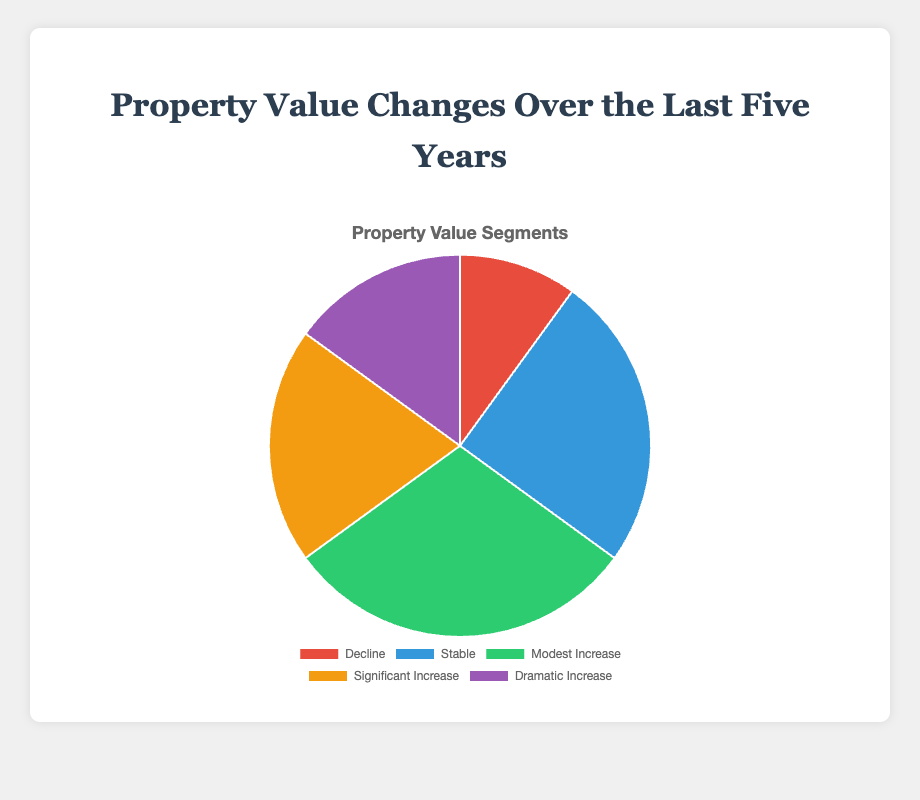Which property value segment has the highest percentage? The visual representation shows that the 'Modest Increase' section occupies the largest area of the pie chart.
Answer: Modest Increase Which two segments together account for exactly 50% of the property values? 'Stable' has 25% and 'Modest Increase' has 30%. Adding these two percentages results in 55%, which is incorrect. 'Significant Increase' has 20%, and adding 'Stable' (25%) results in 45%. Combining 'Dramatic Increase' (15%) and 'Decline' (10%) yields 25%, which is also incorrect. Finally, adding 'Significant Increase' (20%) and 'Dramatic Increase' (15%) results in 35%. The correct answer is 'Stable' and 'Significant Increase'.
Answer: Stable and Significant Increase How much larger, in percentage points, is the 'Significant Increase' segment compared to the 'Decline' segment? The percentage for 'Significant Increase' is 20%, while for 'Decline' it is 10%. Subtracting the two, 20% - 10%, gives the difference.
Answer: 10% What percentage of properties have experienced an increase (modest, significant, or dramatic)? To find the total percentage of properties that have experienced an increase, add the percentages for 'Modest Increase' (30%), 'Significant Increase' (20%), and 'Dramatic Increase' (15%). The sum is 30% + 20% + 15% = 65%.
Answer: 65% Which segment has the smallest percentage, and what is that percentage? The 'Decline' segment is visually the smallest part of the pie chart. The percentage for 'Decline' is 10%.
Answer: Decline, 10% Which two segments together have the same percentage as the 'Modest Increase' segment? First, check which segments sum up to 'Modest Increase' (30%). Starting with 'Decline' (10%) and 'Stable' (25%) yields 35%, which is not correct. Checking 'Decline' (10%) and 'Significant Increase' (20%) results in 30%, which matches 'Modest Increase'. Combining 'Significant Increase' (20%) and 'Dramatic Increase' (15%) gives 35%, which is also incorrect. Thus, 'Decline' and 'Significant Increase' together give 30%.
Answer: Decline and Significant Increase How does the percentage of the 'Stable' segment compare to that of the 'Dramatic Increase' segment? The 'Stable' segment accounts for 25% of the property values, while the 'Dramatic Increase' segment accounts for 15%. Thus, 'Stable' is greater than 'Dramatic Increase'.
Answer: Stable is greater than Dramatic Increase What is the combined percentage of properties that either remained stable or had a modest increase? To calculate the combined percentage, add the 'Stable' segment (25%) and the 'Modest Increase' segment (30%). The total is 55%.
Answer: 55% If the total property value change percentage must equal 100%, how much more would the 'Decline' segment need to increase to equal the 'Stable' segment? The 'Decline' segment is at 10%, and the 'Stable' segment is at 25%. The difference is 25% - 10%, which gives 15%.
Answer: 15% What visual aspect helps identify the segment for 'Dramatic Increase' the quickest? The pie chart uses distinct colors, and the 'Dramatic Increase' segment is purple. The color makes this segment easily identifiable.
Answer: Its purple color 